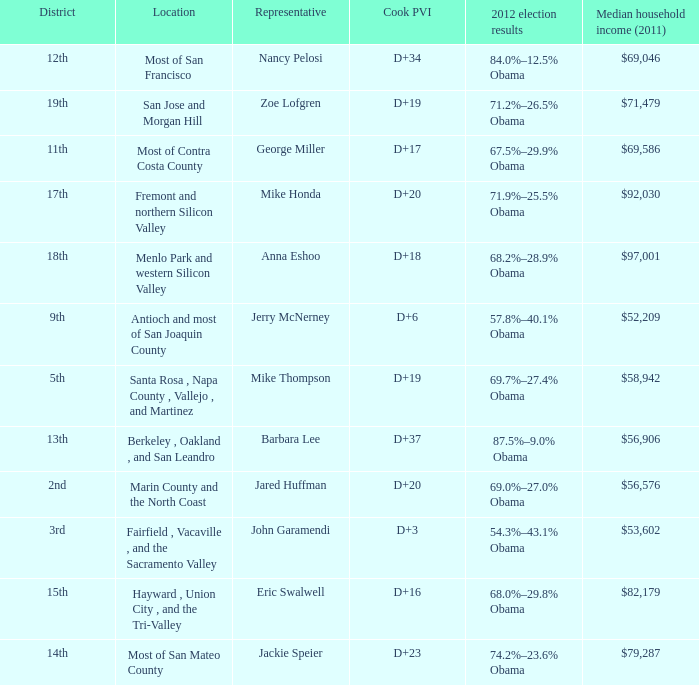What is the Cook PVI for the location that has a representative of Mike Thompson? D+19. 